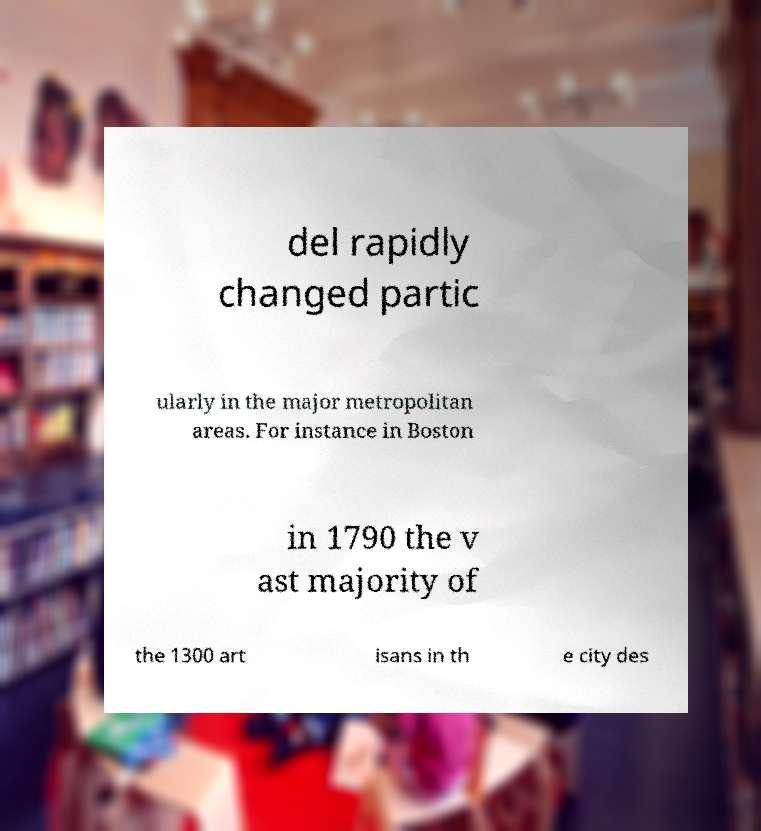I need the written content from this picture converted into text. Can you do that? del rapidly changed partic ularly in the major metropolitan areas. For instance in Boston in 1790 the v ast majority of the 1300 art isans in th e city des 